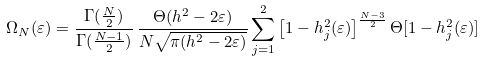<formula> <loc_0><loc_0><loc_500><loc_500>\Omega _ { N } ( \varepsilon ) = \frac { \Gamma ( \frac { N } { 2 } ) } { \Gamma ( \frac { N - 1 } { 2 } ) } \, \frac { \Theta ( h ^ { 2 } - 2 \varepsilon ) } { N \sqrt { \pi ( h ^ { 2 } - 2 \varepsilon ) } } \sum _ { j = 1 } ^ { 2 } \left [ 1 - h _ { j } ^ { 2 } ( \varepsilon ) \right ] ^ { \frac { N - 3 } { 2 } } \Theta [ 1 - h _ { j } ^ { 2 } ( \varepsilon ) ]</formula> 